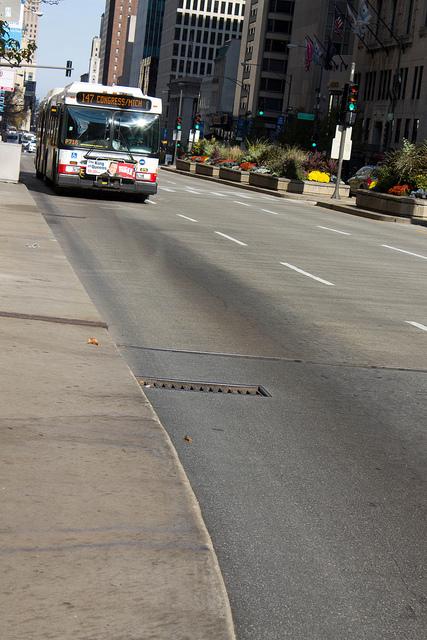Is there a bus driving down the street?
Short answer required. Yes. Is this a one way road?
Short answer required. Yes. What is lining the middle of the road?
Give a very brief answer. Asphalt. 